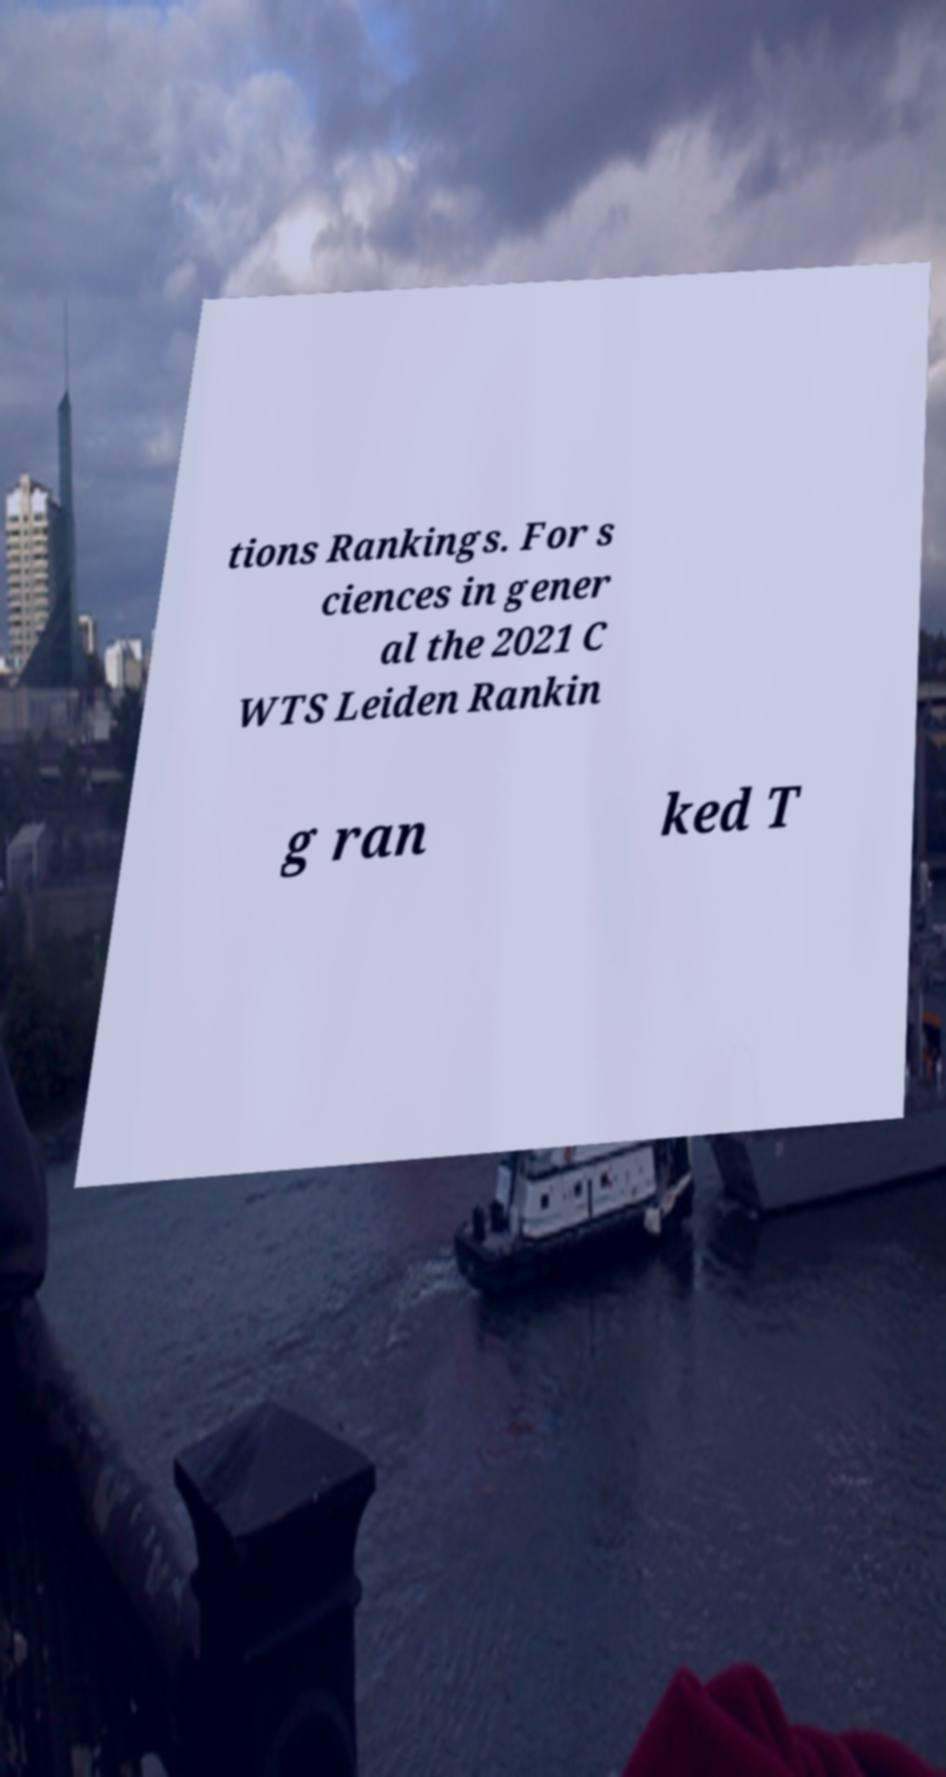Can you read and provide the text displayed in the image?This photo seems to have some interesting text. Can you extract and type it out for me? tions Rankings. For s ciences in gener al the 2021 C WTS Leiden Rankin g ran ked T 